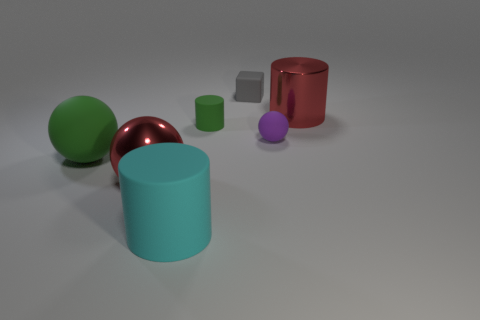How many other things are there of the same size as the metallic sphere?
Your answer should be compact. 3. The small cylinder is what color?
Your response must be concise. Green. What number of metal things are either tiny brown balls or tiny green cylinders?
Your answer should be compact. 0. What size is the red thing that is on the left side of the large cylinder to the right of the large cyan rubber cylinder that is in front of the purple matte thing?
Your answer should be compact. Large. What size is the object that is behind the purple rubber ball and on the right side of the small matte cube?
Your answer should be very brief. Large. Do the small rubber sphere that is right of the big green sphere and the rubber cylinder that is behind the cyan thing have the same color?
Your answer should be very brief. No. There is a big matte cylinder; what number of things are behind it?
Make the answer very short. 6. There is a large cylinder that is in front of the large shiny thing left of the tiny purple thing; are there any tiny purple spheres that are in front of it?
Your answer should be very brief. No. How many spheres are the same size as the green matte cylinder?
Offer a terse response. 1. What is the material of the gray block that is behind the small green object behind the big cyan object?
Offer a terse response. Rubber. 